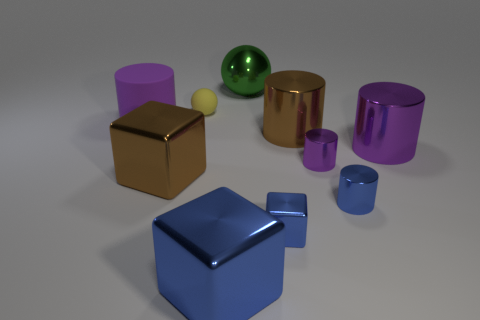How many purple cylinders must be subtracted to get 1 purple cylinders? 2 Subtract all purple spheres. How many purple cylinders are left? 3 Subtract all brown cylinders. How many cylinders are left? 4 Subtract 2 cylinders. How many cylinders are left? 3 Subtract all large brown metallic cylinders. How many cylinders are left? 4 Subtract all red cylinders. Subtract all blue blocks. How many cylinders are left? 5 Subtract all balls. How many objects are left? 8 Add 6 big purple rubber objects. How many big purple rubber objects exist? 7 Subtract 1 green balls. How many objects are left? 9 Subtract all brown rubber blocks. Subtract all rubber cylinders. How many objects are left? 9 